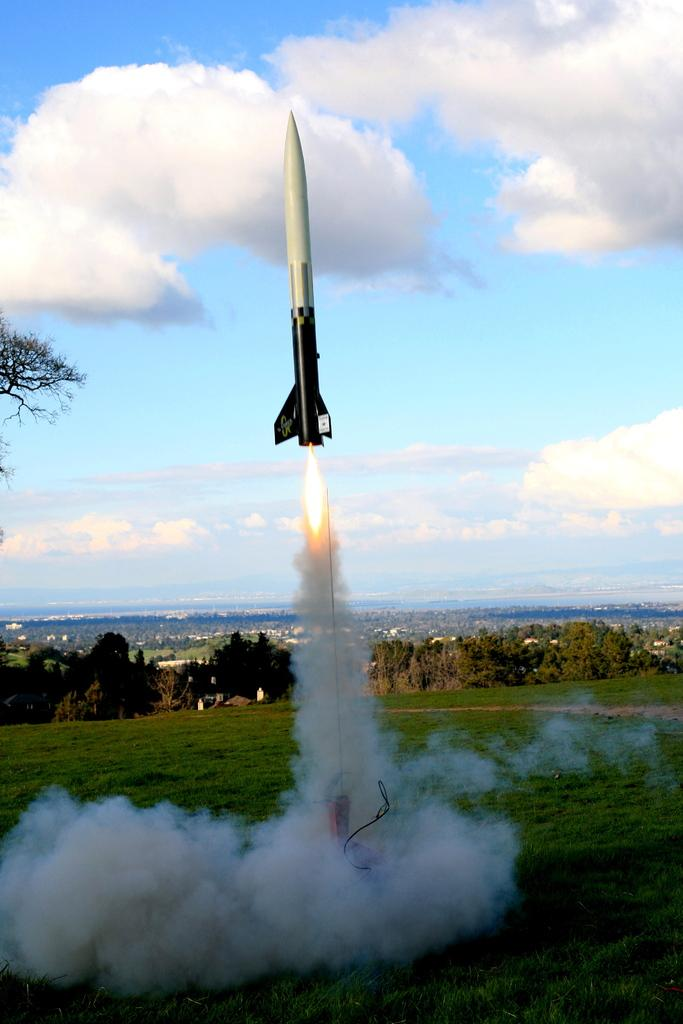What is the main subject in the center of the image? There is a rocket in the center of the image. What can be seen at the bottom side of the image? There are buildings and trees at the bottom side of the image. How many doors can be seen on the rocket in the image? There are no doors visible on the rocket in the image, as it is a vehicle designed for space travel and does not typically have doors like a building or a car. 